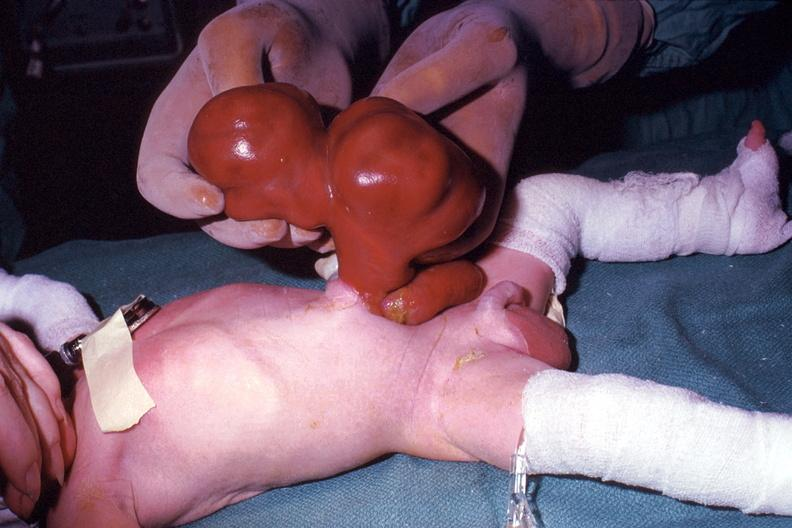what is present?
Answer the question using a single word or phrase. Omphalocele 